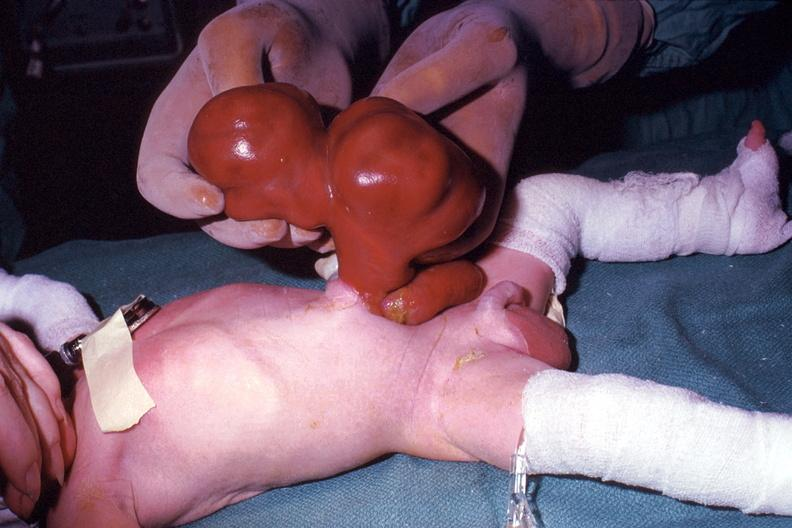what is present?
Answer the question using a single word or phrase. Omphalocele 